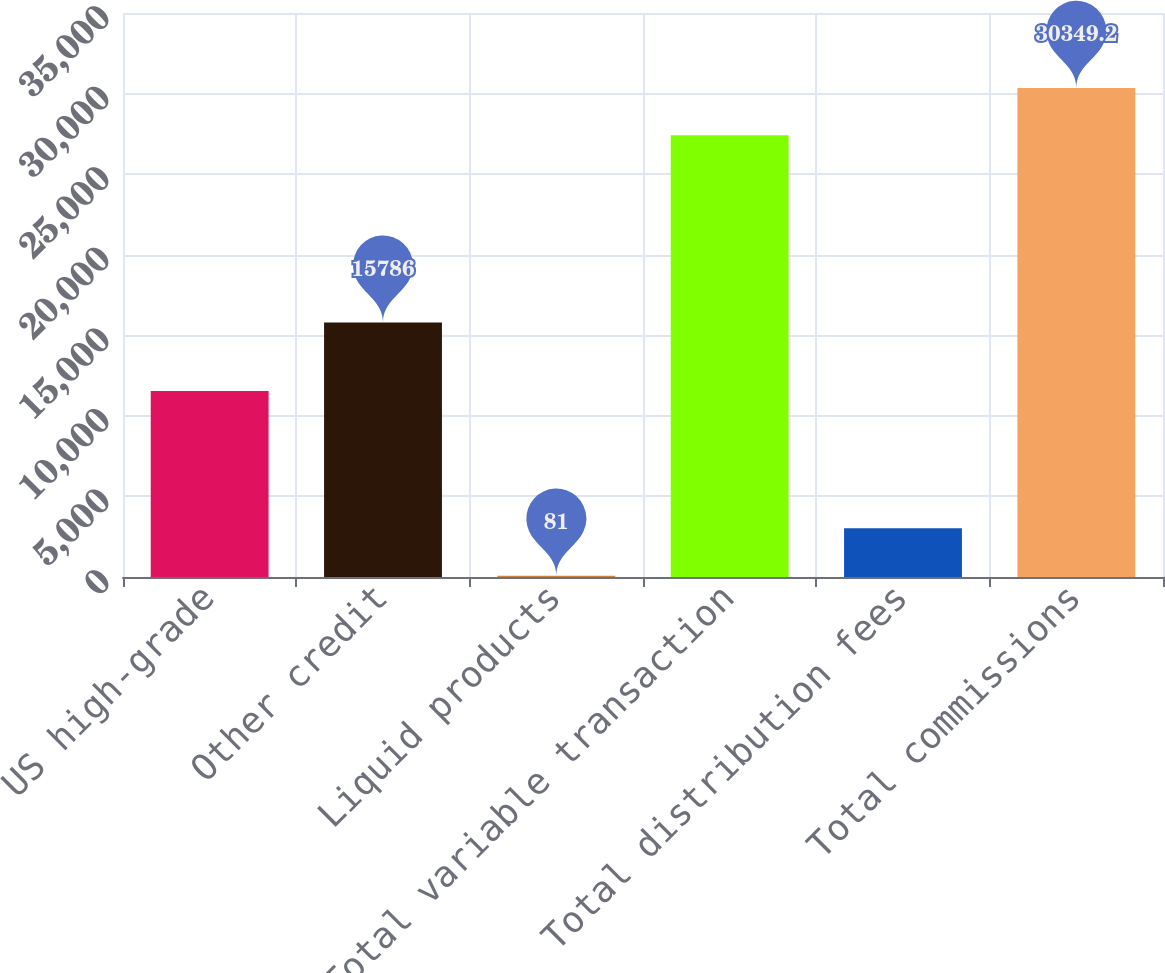Convert chart to OTSL. <chart><loc_0><loc_0><loc_500><loc_500><bar_chart><fcel>US high-grade<fcel>Other credit<fcel>Liquid products<fcel>Total variable transaction<fcel>Total distribution fees<fcel>Total commissions<nl><fcel>11545<fcel>15786<fcel>81<fcel>27412<fcel>3018.2<fcel>30349.2<nl></chart> 